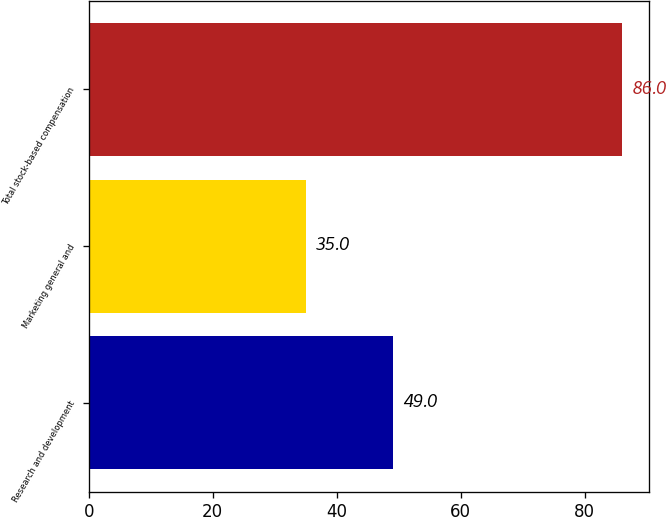Convert chart. <chart><loc_0><loc_0><loc_500><loc_500><bar_chart><fcel>Research and development<fcel>Marketing general and<fcel>Total stock-based compensation<nl><fcel>49<fcel>35<fcel>86<nl></chart> 